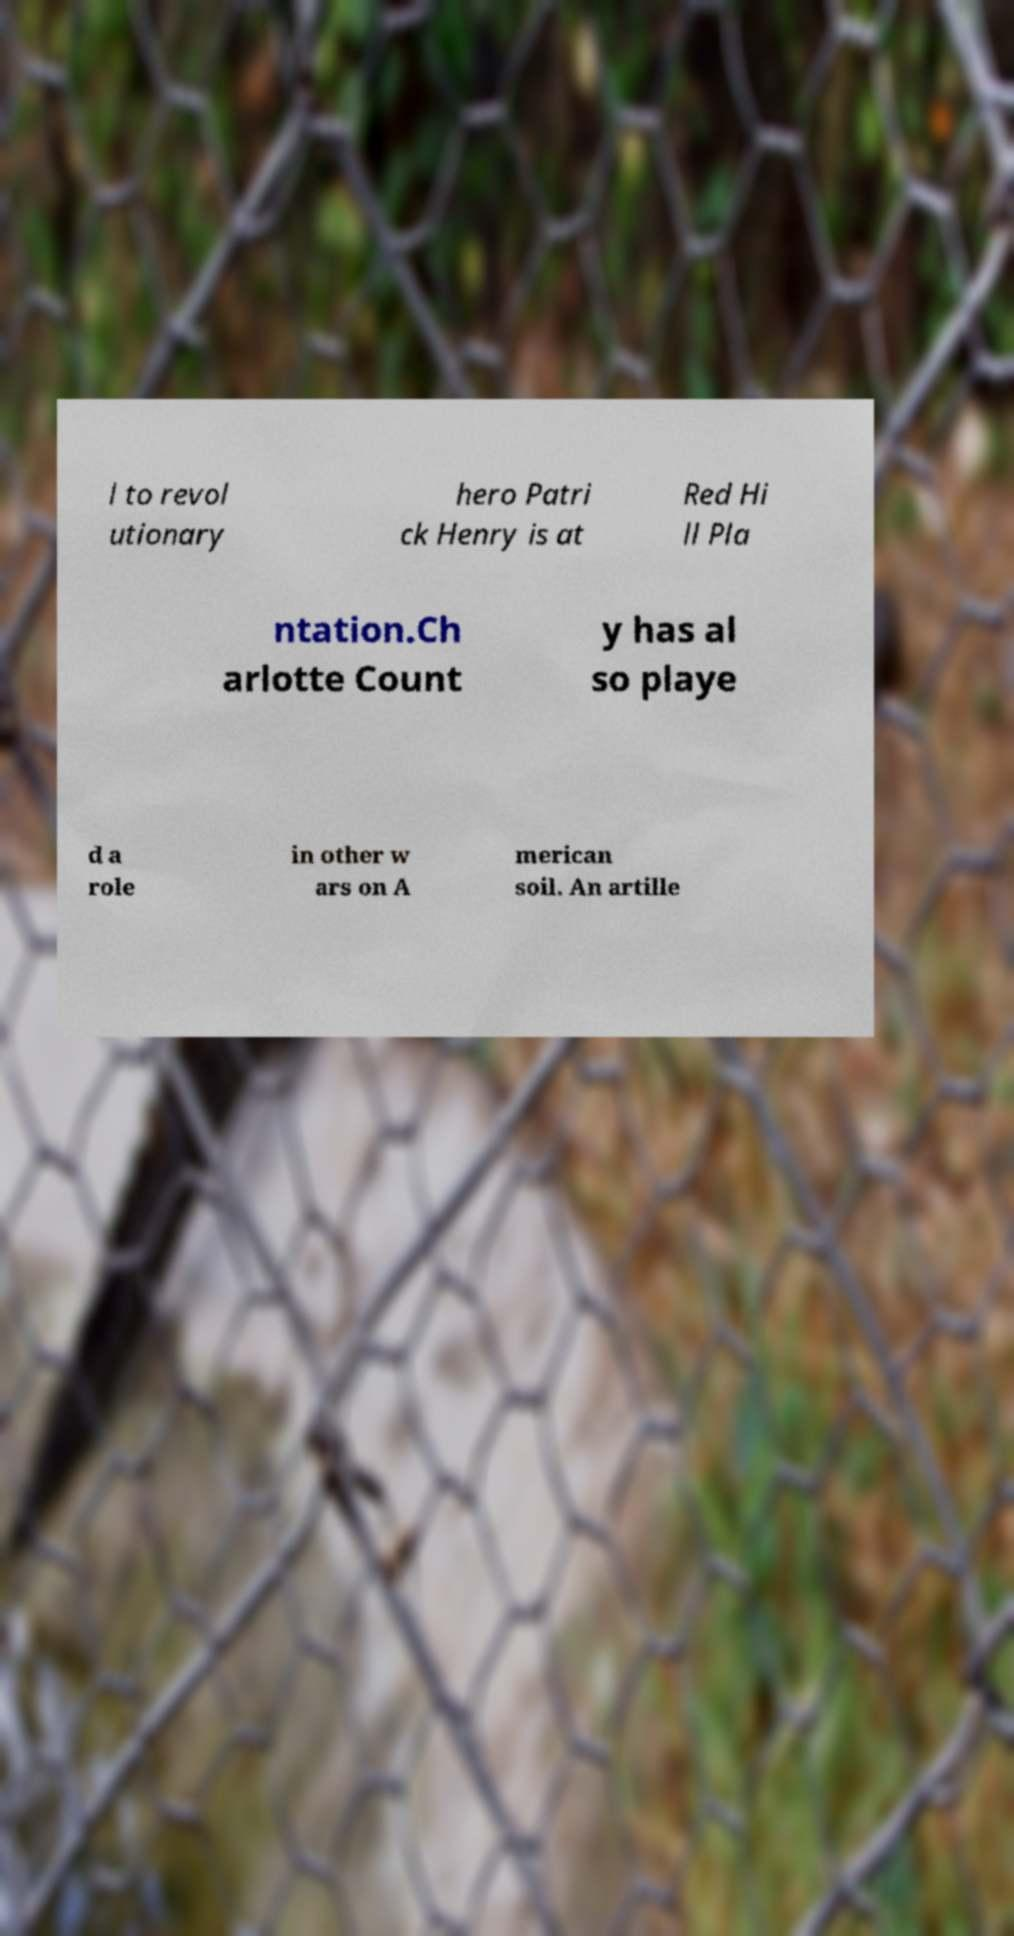Could you assist in decoding the text presented in this image and type it out clearly? l to revol utionary hero Patri ck Henry is at Red Hi ll Pla ntation.Ch arlotte Count y has al so playe d a role in other w ars on A merican soil. An artille 